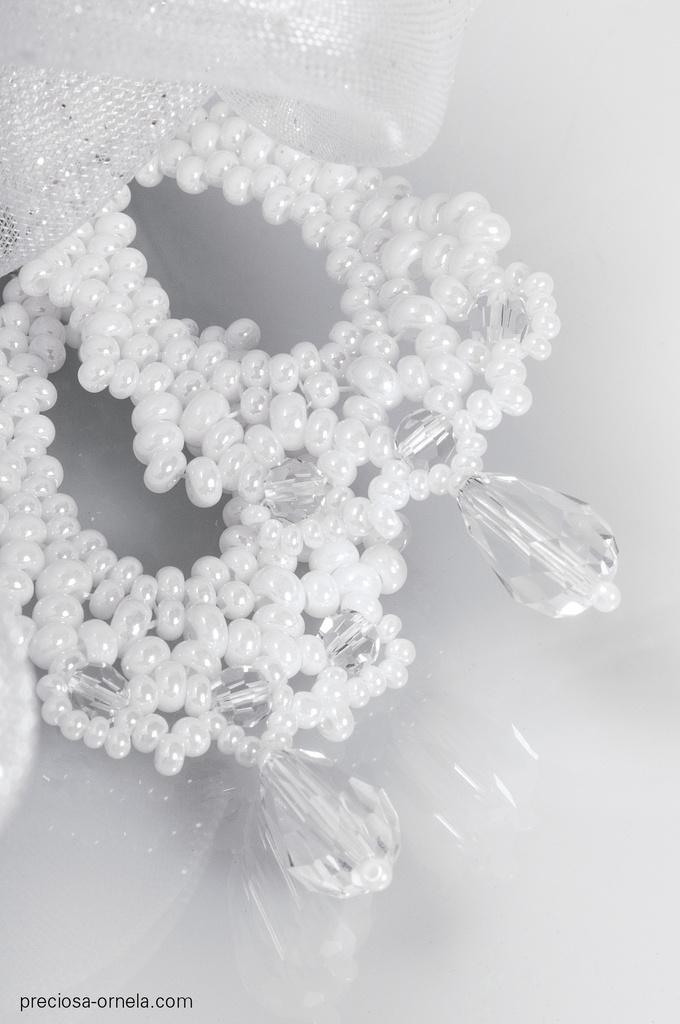Could you give a brief overview of what you see in this image? In the image there are stones and beads. 